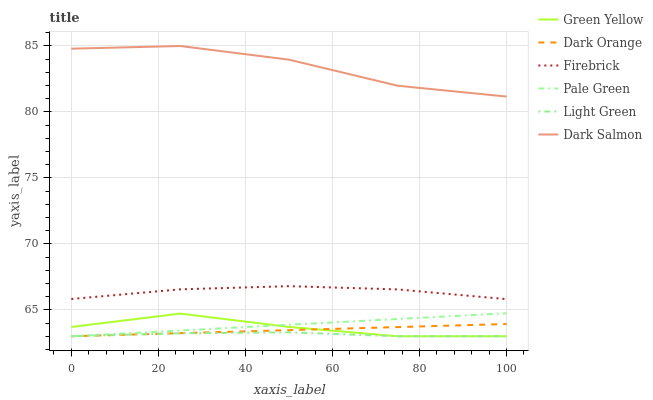Does Firebrick have the minimum area under the curve?
Answer yes or no. No. Does Firebrick have the maximum area under the curve?
Answer yes or no. No. Is Firebrick the smoothest?
Answer yes or no. No. Is Firebrick the roughest?
Answer yes or no. No. Does Firebrick have the lowest value?
Answer yes or no. No. Does Firebrick have the highest value?
Answer yes or no. No. Is Green Yellow less than Firebrick?
Answer yes or no. Yes. Is Dark Salmon greater than Dark Orange?
Answer yes or no. Yes. Does Green Yellow intersect Firebrick?
Answer yes or no. No. 